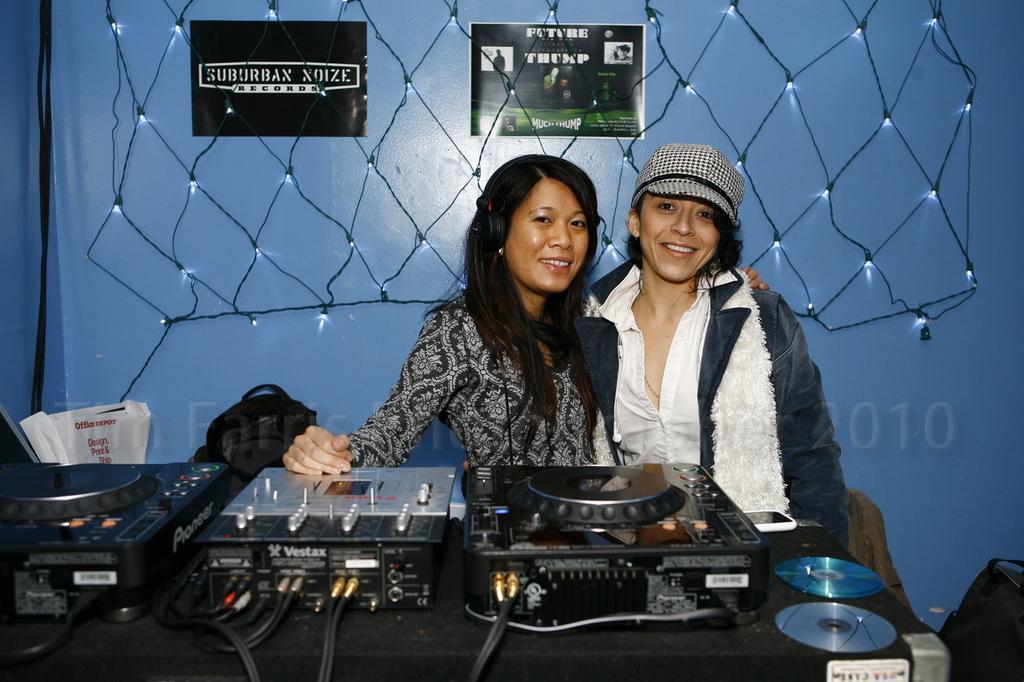How would you summarize this image in a sentence or two? In this image, there are two people smiling. I can see the CD´s and electronic devices, which are placed on the table. These are the lighting´s and posters attached to the wall. I can see the watermark on the image. On the right corner of the image, that looks like a bag. 